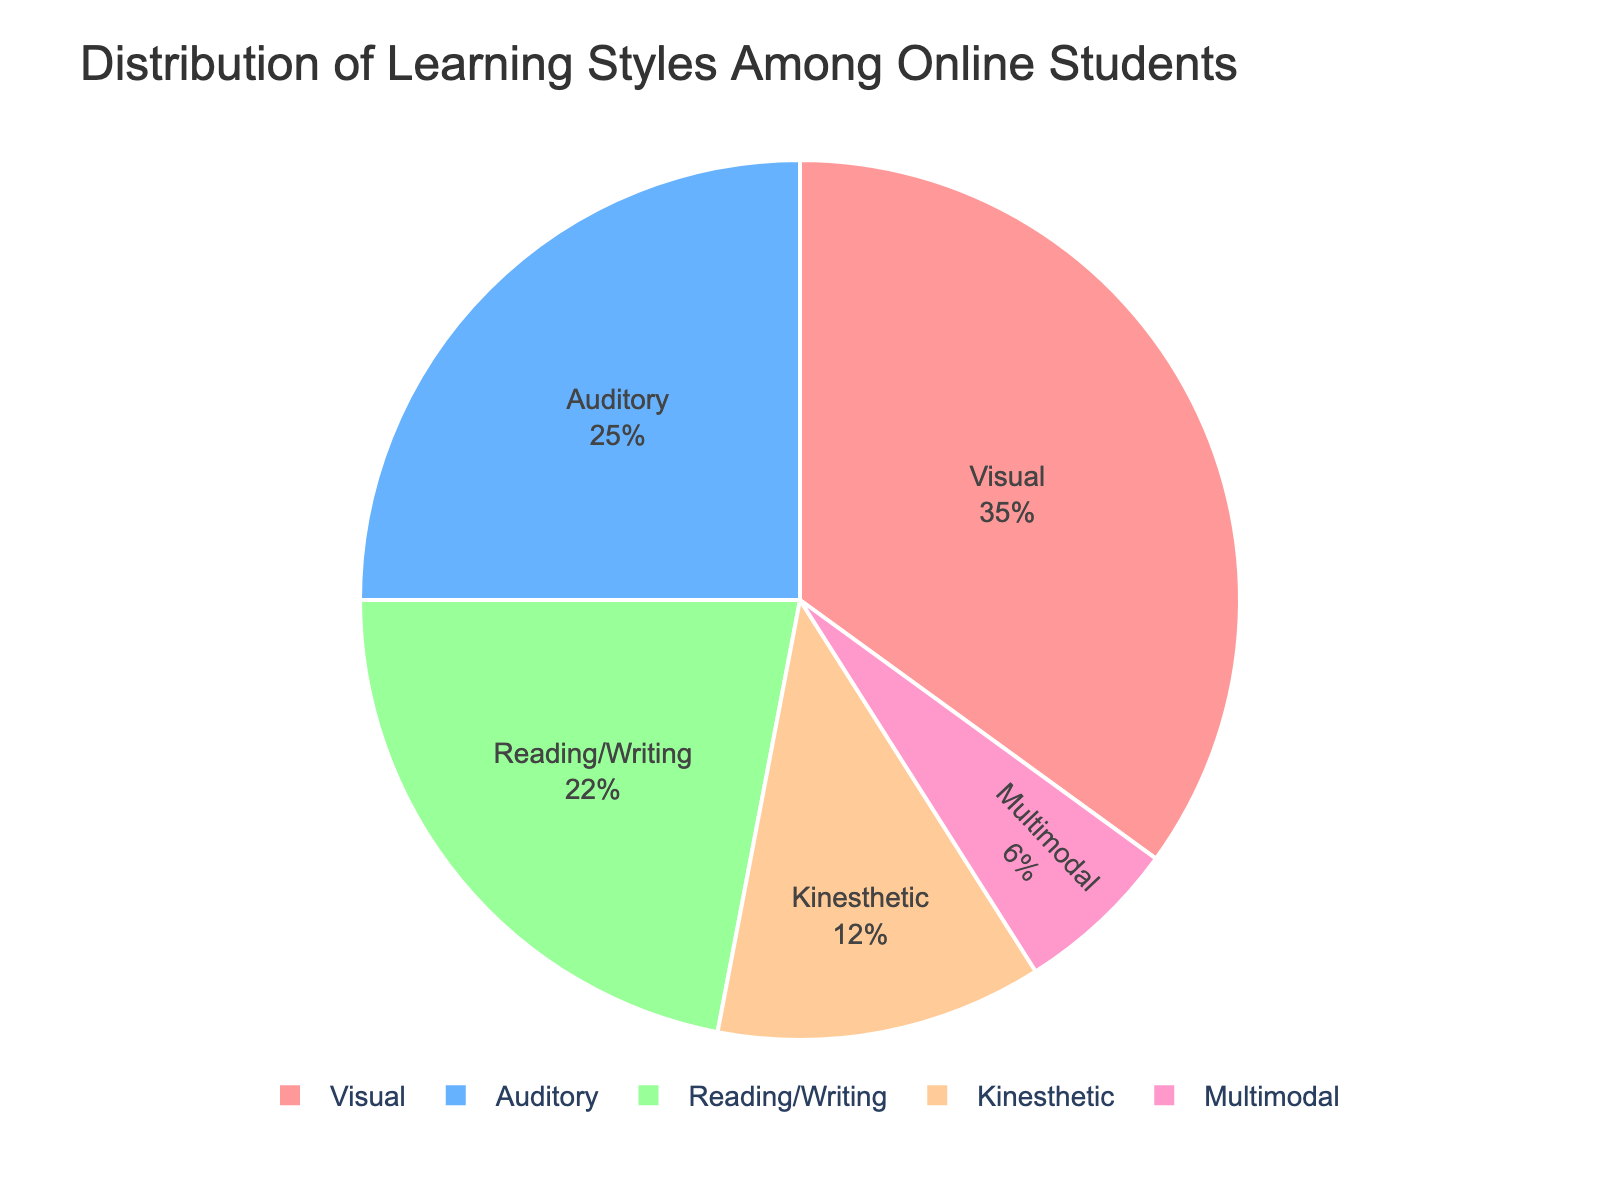What's the most common learning style among online students? Look at the pie chart to identify which segment has the largest share. The "Visual" segment occupies the largest portion.
Answer: Visual By how many percentage points does the "Visual" learning style exceed the "Auditory" learning style? The "Visual" learning style is 35%, and the "Auditory" learning style is 25%. Subtract 25 from 35 to find the difference.
Answer: 10 What is the combined percentage of students who prefer "Reading/Writing" and "Kinesthetic" learning styles? Add the percentages for "Reading/Writing" (22%) and "Kinesthetic" (12%). 22 + 12 = 34%.
Answer: 34% Which learning style has the smallest representation among the students? Identify the smallest segment in the pie chart. The "Multimodal" learning style has the smallest share.
Answer: Multimodal Are there more students who prefer "Reading/Writing" over "Auditory" learning styles? Compare the percentages for "Reading/Writing" (22%) and "Auditory" (25%). "Auditory" is higher than "Reading/Writing."
Answer: No How does the percentage of "Kinesthetic" learners compare to that of "Multimodal" learners? Compare the "Kinesthetic" percentage (12%) to the "Multimodal" percentage (6%). "Kinesthetic" is twice the percentage of "Multimodal."
Answer: Twice as much What is the total percentage of students preferring either "Auditory" or "Multimodal" learning styles? Add the percentages of "Auditory" (25%) and "Multimodal" (6%). 25 + 6 = 31%.
Answer: 31% Which two learning styles have a combined percentage of less than 20%? Check pairs of learning styles whose combined percentage is less than 20%. "Kinesthetic" (12%) and "Multimodal" (6%) add up to 18%, which is less than 20%.
Answer: Kinesthetic and Multimodal What fraction of the students prefer non-sensory learning styles ("Reading/Writing" and "Multimodal")? Add the percentages for "Reading/Writing" (22%) and "Multimodal" (6%), and then calculate the fraction of the total percentage (100%). The combined percentage is 28% or 28/100, which simplifies to 7/25.
Answer: 7/25 